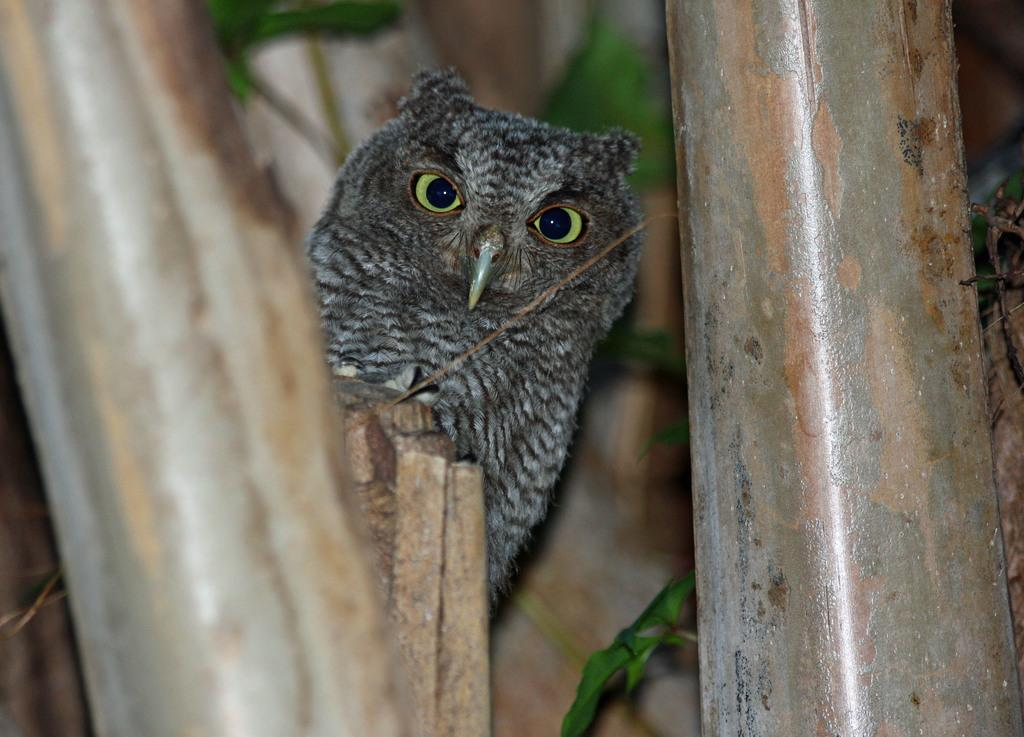What type of animal is in the image? There is an owl in the image. What can be seen in the background of the image? There are leaves in the image. What material are the rods made of in the image? There are iron rods in the image. What emotion is the owl displaying in the image? The image does not show any indication of the owl's emotions, so it cannot be determined from the image. 